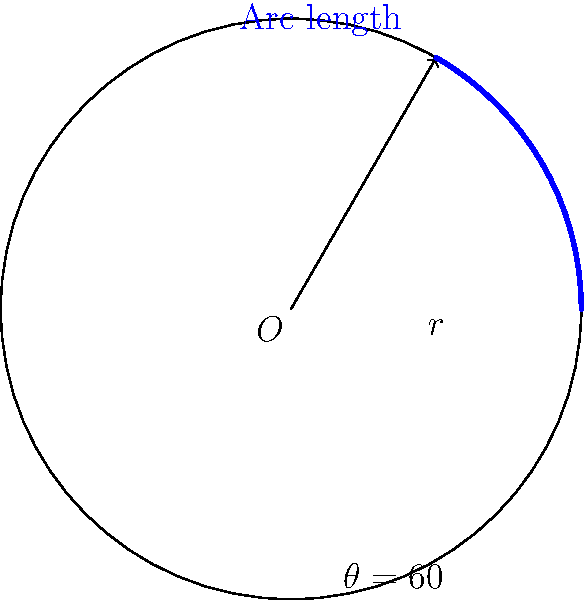A new weather radar system has a circular scanning range with a radius of 150 km. If the radar sweeps through an angle of 60°, what is the arc length covered by the radar beam? Round your answer to the nearest kilometer. To solve this problem, we'll use the formula for arc length:

$s = r\theta$

Where:
$s$ = arc length
$r$ = radius
$\theta$ = central angle in radians

Step 1: Convert the angle from degrees to radians
$\theta = 60° \times \frac{\pi}{180°} = \frac{\pi}{3}$ radians

Step 2: Apply the arc length formula
$s = r\theta$
$s = 150 \text{ km} \times \frac{\pi}{3}$

Step 3: Calculate the result
$s = 50\pi \text{ km}$
$s \approx 157.08 \text{ km}$

Step 4: Round to the nearest kilometer
$s \approx 157 \text{ km}$
Answer: 157 km 